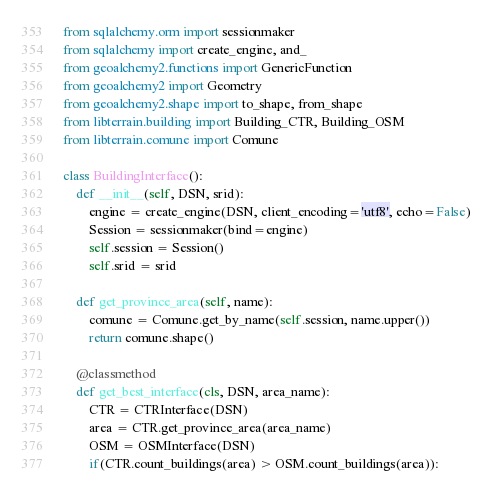Convert code to text. <code><loc_0><loc_0><loc_500><loc_500><_Python_>from sqlalchemy.orm import sessionmaker
from sqlalchemy import create_engine, and_
from geoalchemy2.functions import GenericFunction
from geoalchemy2 import Geometry
from geoalchemy2.shape import to_shape, from_shape
from libterrain.building import Building_CTR, Building_OSM
from libterrain.comune import Comune

class BuildingInterface():
    def __init__(self, DSN, srid):
        engine = create_engine(DSN, client_encoding='utf8', echo=False)
        Session = sessionmaker(bind=engine)
        self.session = Session()
        self.srid = srid

    def get_province_area(self, name):
        comune = Comune.get_by_name(self.session, name.upper())
        return comune.shape()

    @classmethod
    def get_best_interface(cls, DSN, area_name):
        CTR = CTRInterface(DSN)
        area = CTR.get_province_area(area_name)
        OSM = OSMInterface(DSN)
        if(CTR.count_buildings(area) > OSM.count_buildings(area)):</code> 